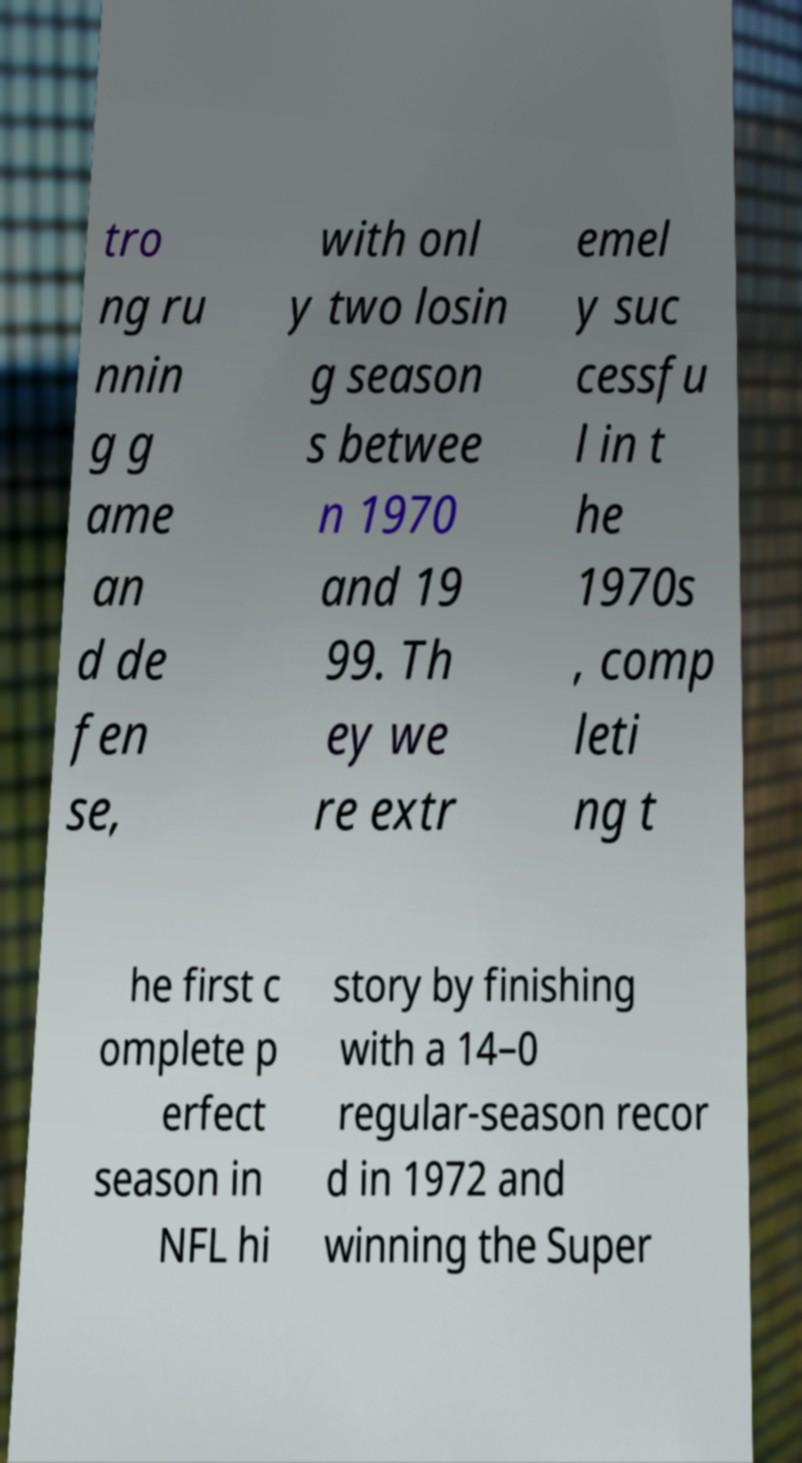Could you assist in decoding the text presented in this image and type it out clearly? tro ng ru nnin g g ame an d de fen se, with onl y two losin g season s betwee n 1970 and 19 99. Th ey we re extr emel y suc cessfu l in t he 1970s , comp leti ng t he first c omplete p erfect season in NFL hi story by finishing with a 14–0 regular-season recor d in 1972 and winning the Super 